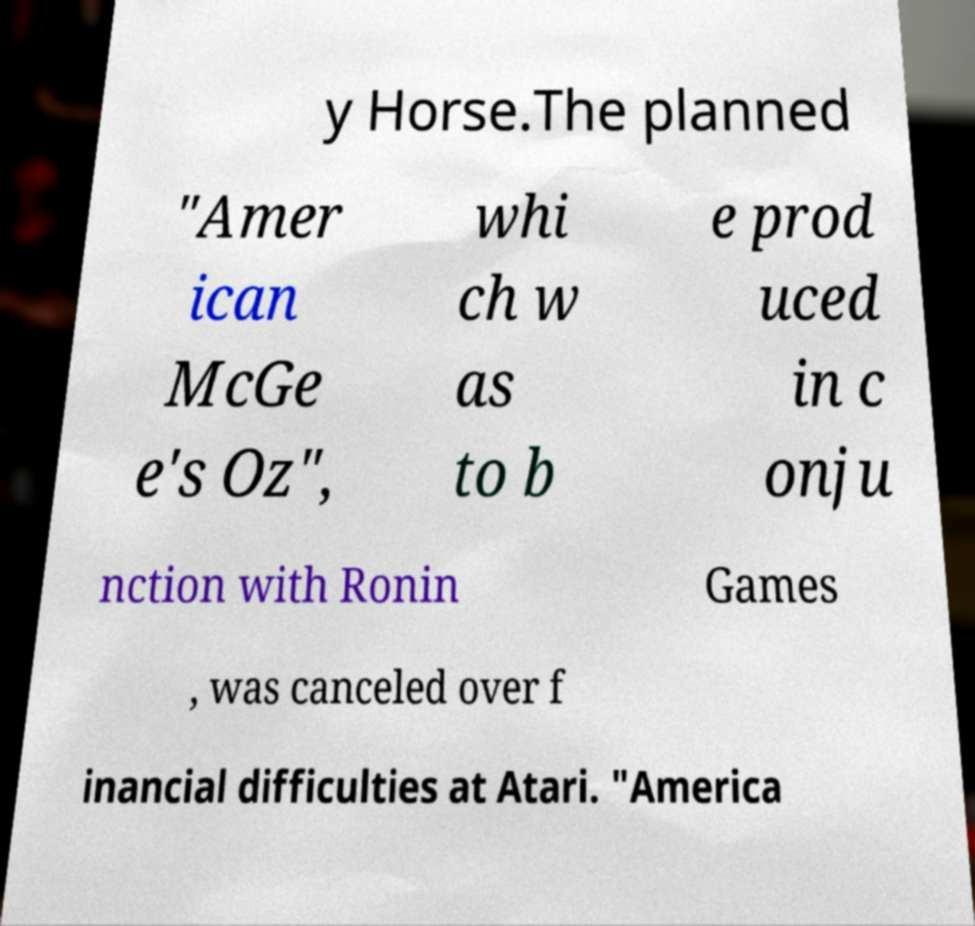I need the written content from this picture converted into text. Can you do that? y Horse.The planned "Amer ican McGe e's Oz", whi ch w as to b e prod uced in c onju nction with Ronin Games , was canceled over f inancial difficulties at Atari. "America 